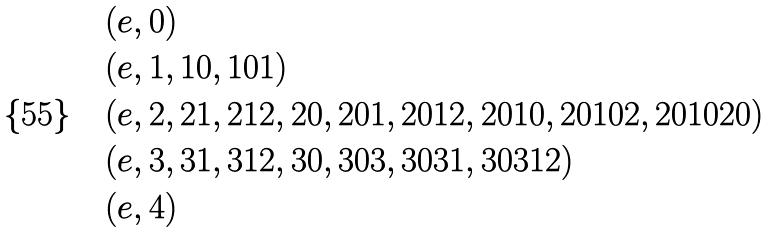<formula> <loc_0><loc_0><loc_500><loc_500>& ( e , 0 ) \\ & ( e , 1 , 1 0 , 1 0 1 ) \\ & ( e , 2 , 2 1 , 2 1 2 , 2 0 , 2 0 1 , 2 0 1 2 , 2 0 1 0 , 2 0 1 0 2 , 2 0 1 0 2 0 ) \\ & ( e , 3 , 3 1 , 3 1 2 , 3 0 , 3 0 3 , 3 0 3 1 , 3 0 3 1 2 ) \\ & ( e , 4 ) \\</formula> 